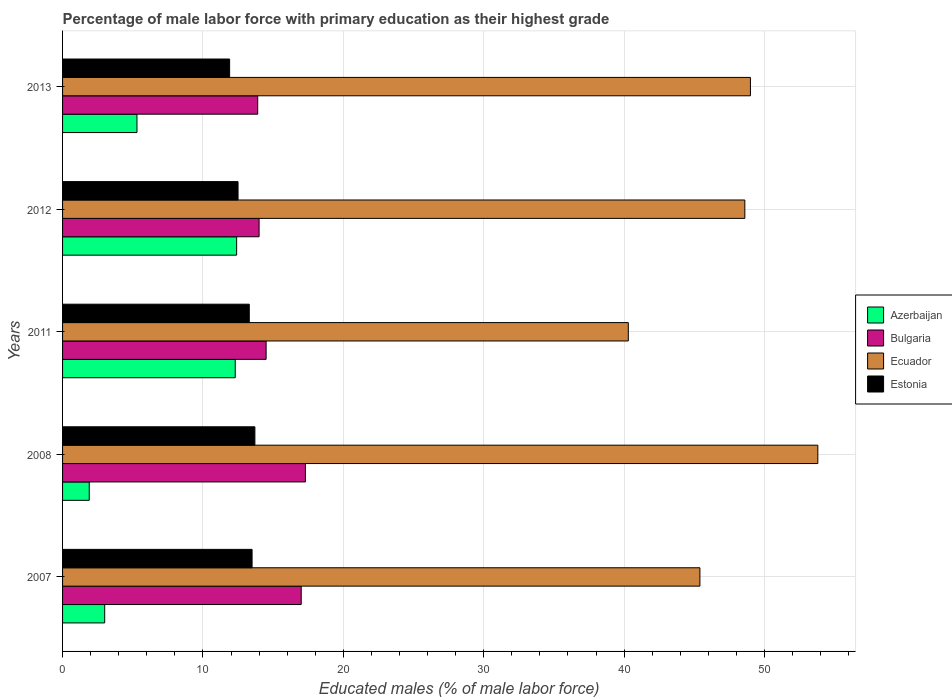How many different coloured bars are there?
Ensure brevity in your answer.  4. Are the number of bars per tick equal to the number of legend labels?
Offer a very short reply. Yes. How many bars are there on the 2nd tick from the top?
Provide a succinct answer. 4. How many bars are there on the 2nd tick from the bottom?
Offer a very short reply. 4. What is the percentage of male labor force with primary education in Bulgaria in 2013?
Ensure brevity in your answer.  13.9. Across all years, what is the maximum percentage of male labor force with primary education in Bulgaria?
Your response must be concise. 17.3. Across all years, what is the minimum percentage of male labor force with primary education in Azerbaijan?
Provide a succinct answer. 1.9. In which year was the percentage of male labor force with primary education in Ecuador minimum?
Ensure brevity in your answer.  2011. What is the total percentage of male labor force with primary education in Bulgaria in the graph?
Make the answer very short. 76.7. What is the difference between the percentage of male labor force with primary education in Estonia in 2012 and that in 2013?
Make the answer very short. 0.6. What is the difference between the percentage of male labor force with primary education in Bulgaria in 2013 and the percentage of male labor force with primary education in Estonia in 2007?
Provide a short and direct response. 0.4. What is the average percentage of male labor force with primary education in Azerbaijan per year?
Your response must be concise. 6.98. In the year 2012, what is the difference between the percentage of male labor force with primary education in Azerbaijan and percentage of male labor force with primary education in Ecuador?
Make the answer very short. -36.2. In how many years, is the percentage of male labor force with primary education in Ecuador greater than 6 %?
Provide a short and direct response. 5. What is the ratio of the percentage of male labor force with primary education in Azerbaijan in 2007 to that in 2012?
Offer a very short reply. 0.24. Is the percentage of male labor force with primary education in Azerbaijan in 2011 less than that in 2012?
Give a very brief answer. Yes. What is the difference between the highest and the second highest percentage of male labor force with primary education in Azerbaijan?
Your answer should be compact. 0.1. What is the difference between the highest and the lowest percentage of male labor force with primary education in Ecuador?
Your answer should be very brief. 13.5. In how many years, is the percentage of male labor force with primary education in Estonia greater than the average percentage of male labor force with primary education in Estonia taken over all years?
Provide a short and direct response. 3. Is it the case that in every year, the sum of the percentage of male labor force with primary education in Estonia and percentage of male labor force with primary education in Azerbaijan is greater than the sum of percentage of male labor force with primary education in Ecuador and percentage of male labor force with primary education in Bulgaria?
Offer a terse response. No. What does the 2nd bar from the top in 2007 represents?
Your response must be concise. Ecuador. Is it the case that in every year, the sum of the percentage of male labor force with primary education in Ecuador and percentage of male labor force with primary education in Bulgaria is greater than the percentage of male labor force with primary education in Azerbaijan?
Offer a very short reply. Yes. How many bars are there?
Keep it short and to the point. 20. Are all the bars in the graph horizontal?
Offer a very short reply. Yes. Are the values on the major ticks of X-axis written in scientific E-notation?
Your answer should be compact. No. Does the graph contain any zero values?
Give a very brief answer. No. Does the graph contain grids?
Provide a short and direct response. Yes. Where does the legend appear in the graph?
Provide a short and direct response. Center right. How are the legend labels stacked?
Provide a succinct answer. Vertical. What is the title of the graph?
Your answer should be very brief. Percentage of male labor force with primary education as their highest grade. What is the label or title of the X-axis?
Provide a succinct answer. Educated males (% of male labor force). What is the label or title of the Y-axis?
Give a very brief answer. Years. What is the Educated males (% of male labor force) of Azerbaijan in 2007?
Your response must be concise. 3. What is the Educated males (% of male labor force) of Bulgaria in 2007?
Your answer should be compact. 17. What is the Educated males (% of male labor force) in Ecuador in 2007?
Provide a succinct answer. 45.4. What is the Educated males (% of male labor force) of Estonia in 2007?
Make the answer very short. 13.5. What is the Educated males (% of male labor force) in Azerbaijan in 2008?
Give a very brief answer. 1.9. What is the Educated males (% of male labor force) in Bulgaria in 2008?
Provide a short and direct response. 17.3. What is the Educated males (% of male labor force) of Ecuador in 2008?
Your answer should be compact. 53.8. What is the Educated males (% of male labor force) in Estonia in 2008?
Ensure brevity in your answer.  13.7. What is the Educated males (% of male labor force) of Azerbaijan in 2011?
Provide a succinct answer. 12.3. What is the Educated males (% of male labor force) of Bulgaria in 2011?
Your answer should be compact. 14.5. What is the Educated males (% of male labor force) of Ecuador in 2011?
Your answer should be very brief. 40.3. What is the Educated males (% of male labor force) of Estonia in 2011?
Offer a very short reply. 13.3. What is the Educated males (% of male labor force) in Azerbaijan in 2012?
Provide a succinct answer. 12.4. What is the Educated males (% of male labor force) of Ecuador in 2012?
Provide a succinct answer. 48.6. What is the Educated males (% of male labor force) in Azerbaijan in 2013?
Your response must be concise. 5.3. What is the Educated males (% of male labor force) in Bulgaria in 2013?
Offer a very short reply. 13.9. What is the Educated males (% of male labor force) of Ecuador in 2013?
Provide a succinct answer. 49. What is the Educated males (% of male labor force) in Estonia in 2013?
Offer a very short reply. 11.9. Across all years, what is the maximum Educated males (% of male labor force) of Azerbaijan?
Offer a very short reply. 12.4. Across all years, what is the maximum Educated males (% of male labor force) in Bulgaria?
Offer a very short reply. 17.3. Across all years, what is the maximum Educated males (% of male labor force) in Ecuador?
Provide a succinct answer. 53.8. Across all years, what is the maximum Educated males (% of male labor force) in Estonia?
Ensure brevity in your answer.  13.7. Across all years, what is the minimum Educated males (% of male labor force) in Azerbaijan?
Make the answer very short. 1.9. Across all years, what is the minimum Educated males (% of male labor force) in Bulgaria?
Your answer should be very brief. 13.9. Across all years, what is the minimum Educated males (% of male labor force) of Ecuador?
Your response must be concise. 40.3. Across all years, what is the minimum Educated males (% of male labor force) of Estonia?
Offer a very short reply. 11.9. What is the total Educated males (% of male labor force) in Azerbaijan in the graph?
Your answer should be very brief. 34.9. What is the total Educated males (% of male labor force) in Bulgaria in the graph?
Ensure brevity in your answer.  76.7. What is the total Educated males (% of male labor force) of Ecuador in the graph?
Your response must be concise. 237.1. What is the total Educated males (% of male labor force) of Estonia in the graph?
Provide a succinct answer. 64.9. What is the difference between the Educated males (% of male labor force) in Azerbaijan in 2007 and that in 2008?
Give a very brief answer. 1.1. What is the difference between the Educated males (% of male labor force) in Bulgaria in 2007 and that in 2008?
Make the answer very short. -0.3. What is the difference between the Educated males (% of male labor force) in Ecuador in 2007 and that in 2011?
Keep it short and to the point. 5.1. What is the difference between the Educated males (% of male labor force) in Bulgaria in 2007 and that in 2012?
Give a very brief answer. 3. What is the difference between the Educated males (% of male labor force) of Ecuador in 2007 and that in 2012?
Provide a short and direct response. -3.2. What is the difference between the Educated males (% of male labor force) in Estonia in 2007 and that in 2012?
Your answer should be compact. 1. What is the difference between the Educated males (% of male labor force) of Ecuador in 2007 and that in 2013?
Provide a succinct answer. -3.6. What is the difference between the Educated males (% of male labor force) of Ecuador in 2008 and that in 2011?
Ensure brevity in your answer.  13.5. What is the difference between the Educated males (% of male labor force) of Estonia in 2008 and that in 2011?
Your response must be concise. 0.4. What is the difference between the Educated males (% of male labor force) in Bulgaria in 2008 and that in 2012?
Provide a succinct answer. 3.3. What is the difference between the Educated males (% of male labor force) in Azerbaijan in 2008 and that in 2013?
Give a very brief answer. -3.4. What is the difference between the Educated males (% of male labor force) of Bulgaria in 2008 and that in 2013?
Offer a very short reply. 3.4. What is the difference between the Educated males (% of male labor force) of Ecuador in 2008 and that in 2013?
Provide a short and direct response. 4.8. What is the difference between the Educated males (% of male labor force) of Bulgaria in 2011 and that in 2013?
Offer a terse response. 0.6. What is the difference between the Educated males (% of male labor force) of Estonia in 2011 and that in 2013?
Offer a terse response. 1.4. What is the difference between the Educated males (% of male labor force) in Bulgaria in 2012 and that in 2013?
Provide a short and direct response. 0.1. What is the difference between the Educated males (% of male labor force) in Ecuador in 2012 and that in 2013?
Your answer should be very brief. -0.4. What is the difference between the Educated males (% of male labor force) in Azerbaijan in 2007 and the Educated males (% of male labor force) in Bulgaria in 2008?
Give a very brief answer. -14.3. What is the difference between the Educated males (% of male labor force) in Azerbaijan in 2007 and the Educated males (% of male labor force) in Ecuador in 2008?
Your answer should be compact. -50.8. What is the difference between the Educated males (% of male labor force) of Azerbaijan in 2007 and the Educated males (% of male labor force) of Estonia in 2008?
Provide a short and direct response. -10.7. What is the difference between the Educated males (% of male labor force) of Bulgaria in 2007 and the Educated males (% of male labor force) of Ecuador in 2008?
Keep it short and to the point. -36.8. What is the difference between the Educated males (% of male labor force) of Bulgaria in 2007 and the Educated males (% of male labor force) of Estonia in 2008?
Ensure brevity in your answer.  3.3. What is the difference between the Educated males (% of male labor force) of Ecuador in 2007 and the Educated males (% of male labor force) of Estonia in 2008?
Keep it short and to the point. 31.7. What is the difference between the Educated males (% of male labor force) of Azerbaijan in 2007 and the Educated males (% of male labor force) of Bulgaria in 2011?
Your answer should be compact. -11.5. What is the difference between the Educated males (% of male labor force) of Azerbaijan in 2007 and the Educated males (% of male labor force) of Ecuador in 2011?
Offer a terse response. -37.3. What is the difference between the Educated males (% of male labor force) of Bulgaria in 2007 and the Educated males (% of male labor force) of Ecuador in 2011?
Make the answer very short. -23.3. What is the difference between the Educated males (% of male labor force) in Ecuador in 2007 and the Educated males (% of male labor force) in Estonia in 2011?
Your answer should be very brief. 32.1. What is the difference between the Educated males (% of male labor force) in Azerbaijan in 2007 and the Educated males (% of male labor force) in Bulgaria in 2012?
Your response must be concise. -11. What is the difference between the Educated males (% of male labor force) in Azerbaijan in 2007 and the Educated males (% of male labor force) in Ecuador in 2012?
Ensure brevity in your answer.  -45.6. What is the difference between the Educated males (% of male labor force) of Bulgaria in 2007 and the Educated males (% of male labor force) of Ecuador in 2012?
Provide a succinct answer. -31.6. What is the difference between the Educated males (% of male labor force) of Ecuador in 2007 and the Educated males (% of male labor force) of Estonia in 2012?
Offer a terse response. 32.9. What is the difference between the Educated males (% of male labor force) of Azerbaijan in 2007 and the Educated males (% of male labor force) of Bulgaria in 2013?
Give a very brief answer. -10.9. What is the difference between the Educated males (% of male labor force) in Azerbaijan in 2007 and the Educated males (% of male labor force) in Ecuador in 2013?
Offer a very short reply. -46. What is the difference between the Educated males (% of male labor force) of Azerbaijan in 2007 and the Educated males (% of male labor force) of Estonia in 2013?
Provide a succinct answer. -8.9. What is the difference between the Educated males (% of male labor force) of Bulgaria in 2007 and the Educated males (% of male labor force) of Ecuador in 2013?
Make the answer very short. -32. What is the difference between the Educated males (% of male labor force) of Ecuador in 2007 and the Educated males (% of male labor force) of Estonia in 2013?
Your answer should be compact. 33.5. What is the difference between the Educated males (% of male labor force) of Azerbaijan in 2008 and the Educated males (% of male labor force) of Ecuador in 2011?
Provide a short and direct response. -38.4. What is the difference between the Educated males (% of male labor force) of Bulgaria in 2008 and the Educated males (% of male labor force) of Estonia in 2011?
Your answer should be very brief. 4. What is the difference between the Educated males (% of male labor force) of Ecuador in 2008 and the Educated males (% of male labor force) of Estonia in 2011?
Your answer should be compact. 40.5. What is the difference between the Educated males (% of male labor force) of Azerbaijan in 2008 and the Educated males (% of male labor force) of Bulgaria in 2012?
Offer a terse response. -12.1. What is the difference between the Educated males (% of male labor force) of Azerbaijan in 2008 and the Educated males (% of male labor force) of Ecuador in 2012?
Give a very brief answer. -46.7. What is the difference between the Educated males (% of male labor force) in Bulgaria in 2008 and the Educated males (% of male labor force) in Ecuador in 2012?
Your answer should be compact. -31.3. What is the difference between the Educated males (% of male labor force) of Bulgaria in 2008 and the Educated males (% of male labor force) of Estonia in 2012?
Keep it short and to the point. 4.8. What is the difference between the Educated males (% of male labor force) in Ecuador in 2008 and the Educated males (% of male labor force) in Estonia in 2012?
Your response must be concise. 41.3. What is the difference between the Educated males (% of male labor force) of Azerbaijan in 2008 and the Educated males (% of male labor force) of Ecuador in 2013?
Provide a short and direct response. -47.1. What is the difference between the Educated males (% of male labor force) in Bulgaria in 2008 and the Educated males (% of male labor force) in Ecuador in 2013?
Provide a short and direct response. -31.7. What is the difference between the Educated males (% of male labor force) in Bulgaria in 2008 and the Educated males (% of male labor force) in Estonia in 2013?
Your response must be concise. 5.4. What is the difference between the Educated males (% of male labor force) in Ecuador in 2008 and the Educated males (% of male labor force) in Estonia in 2013?
Keep it short and to the point. 41.9. What is the difference between the Educated males (% of male labor force) in Azerbaijan in 2011 and the Educated males (% of male labor force) in Bulgaria in 2012?
Provide a short and direct response. -1.7. What is the difference between the Educated males (% of male labor force) in Azerbaijan in 2011 and the Educated males (% of male labor force) in Ecuador in 2012?
Your answer should be very brief. -36.3. What is the difference between the Educated males (% of male labor force) in Azerbaijan in 2011 and the Educated males (% of male labor force) in Estonia in 2012?
Your response must be concise. -0.2. What is the difference between the Educated males (% of male labor force) in Bulgaria in 2011 and the Educated males (% of male labor force) in Ecuador in 2012?
Offer a terse response. -34.1. What is the difference between the Educated males (% of male labor force) in Ecuador in 2011 and the Educated males (% of male labor force) in Estonia in 2012?
Your answer should be compact. 27.8. What is the difference between the Educated males (% of male labor force) of Azerbaijan in 2011 and the Educated males (% of male labor force) of Ecuador in 2013?
Your response must be concise. -36.7. What is the difference between the Educated males (% of male labor force) of Bulgaria in 2011 and the Educated males (% of male labor force) of Ecuador in 2013?
Ensure brevity in your answer.  -34.5. What is the difference between the Educated males (% of male labor force) in Ecuador in 2011 and the Educated males (% of male labor force) in Estonia in 2013?
Give a very brief answer. 28.4. What is the difference between the Educated males (% of male labor force) of Azerbaijan in 2012 and the Educated males (% of male labor force) of Bulgaria in 2013?
Make the answer very short. -1.5. What is the difference between the Educated males (% of male labor force) of Azerbaijan in 2012 and the Educated males (% of male labor force) of Ecuador in 2013?
Give a very brief answer. -36.6. What is the difference between the Educated males (% of male labor force) in Azerbaijan in 2012 and the Educated males (% of male labor force) in Estonia in 2013?
Give a very brief answer. 0.5. What is the difference between the Educated males (% of male labor force) in Bulgaria in 2012 and the Educated males (% of male labor force) in Ecuador in 2013?
Your answer should be very brief. -35. What is the difference between the Educated males (% of male labor force) in Ecuador in 2012 and the Educated males (% of male labor force) in Estonia in 2013?
Your response must be concise. 36.7. What is the average Educated males (% of male labor force) in Azerbaijan per year?
Give a very brief answer. 6.98. What is the average Educated males (% of male labor force) of Bulgaria per year?
Provide a short and direct response. 15.34. What is the average Educated males (% of male labor force) of Ecuador per year?
Your answer should be very brief. 47.42. What is the average Educated males (% of male labor force) of Estonia per year?
Your response must be concise. 12.98. In the year 2007, what is the difference between the Educated males (% of male labor force) of Azerbaijan and Educated males (% of male labor force) of Bulgaria?
Your answer should be very brief. -14. In the year 2007, what is the difference between the Educated males (% of male labor force) in Azerbaijan and Educated males (% of male labor force) in Ecuador?
Your answer should be compact. -42.4. In the year 2007, what is the difference between the Educated males (% of male labor force) of Azerbaijan and Educated males (% of male labor force) of Estonia?
Your answer should be very brief. -10.5. In the year 2007, what is the difference between the Educated males (% of male labor force) of Bulgaria and Educated males (% of male labor force) of Ecuador?
Ensure brevity in your answer.  -28.4. In the year 2007, what is the difference between the Educated males (% of male labor force) of Ecuador and Educated males (% of male labor force) of Estonia?
Your answer should be very brief. 31.9. In the year 2008, what is the difference between the Educated males (% of male labor force) in Azerbaijan and Educated males (% of male labor force) in Bulgaria?
Your answer should be compact. -15.4. In the year 2008, what is the difference between the Educated males (% of male labor force) in Azerbaijan and Educated males (% of male labor force) in Ecuador?
Offer a very short reply. -51.9. In the year 2008, what is the difference between the Educated males (% of male labor force) of Bulgaria and Educated males (% of male labor force) of Ecuador?
Your answer should be very brief. -36.5. In the year 2008, what is the difference between the Educated males (% of male labor force) in Bulgaria and Educated males (% of male labor force) in Estonia?
Provide a short and direct response. 3.6. In the year 2008, what is the difference between the Educated males (% of male labor force) of Ecuador and Educated males (% of male labor force) of Estonia?
Make the answer very short. 40.1. In the year 2011, what is the difference between the Educated males (% of male labor force) of Azerbaijan and Educated males (% of male labor force) of Ecuador?
Provide a short and direct response. -28. In the year 2011, what is the difference between the Educated males (% of male labor force) of Bulgaria and Educated males (% of male labor force) of Ecuador?
Offer a terse response. -25.8. In the year 2011, what is the difference between the Educated males (% of male labor force) of Bulgaria and Educated males (% of male labor force) of Estonia?
Offer a very short reply. 1.2. In the year 2012, what is the difference between the Educated males (% of male labor force) in Azerbaijan and Educated males (% of male labor force) in Ecuador?
Offer a very short reply. -36.2. In the year 2012, what is the difference between the Educated males (% of male labor force) in Azerbaijan and Educated males (% of male labor force) in Estonia?
Provide a short and direct response. -0.1. In the year 2012, what is the difference between the Educated males (% of male labor force) of Bulgaria and Educated males (% of male labor force) of Ecuador?
Keep it short and to the point. -34.6. In the year 2012, what is the difference between the Educated males (% of male labor force) of Bulgaria and Educated males (% of male labor force) of Estonia?
Provide a succinct answer. 1.5. In the year 2012, what is the difference between the Educated males (% of male labor force) in Ecuador and Educated males (% of male labor force) in Estonia?
Keep it short and to the point. 36.1. In the year 2013, what is the difference between the Educated males (% of male labor force) in Azerbaijan and Educated males (% of male labor force) in Bulgaria?
Your answer should be compact. -8.6. In the year 2013, what is the difference between the Educated males (% of male labor force) in Azerbaijan and Educated males (% of male labor force) in Ecuador?
Offer a terse response. -43.7. In the year 2013, what is the difference between the Educated males (% of male labor force) of Azerbaijan and Educated males (% of male labor force) of Estonia?
Your response must be concise. -6.6. In the year 2013, what is the difference between the Educated males (% of male labor force) of Bulgaria and Educated males (% of male labor force) of Ecuador?
Give a very brief answer. -35.1. In the year 2013, what is the difference between the Educated males (% of male labor force) of Bulgaria and Educated males (% of male labor force) of Estonia?
Ensure brevity in your answer.  2. In the year 2013, what is the difference between the Educated males (% of male labor force) in Ecuador and Educated males (% of male labor force) in Estonia?
Provide a succinct answer. 37.1. What is the ratio of the Educated males (% of male labor force) in Azerbaijan in 2007 to that in 2008?
Provide a short and direct response. 1.58. What is the ratio of the Educated males (% of male labor force) in Bulgaria in 2007 to that in 2008?
Provide a short and direct response. 0.98. What is the ratio of the Educated males (% of male labor force) in Ecuador in 2007 to that in 2008?
Your response must be concise. 0.84. What is the ratio of the Educated males (% of male labor force) in Estonia in 2007 to that in 2008?
Make the answer very short. 0.99. What is the ratio of the Educated males (% of male labor force) of Azerbaijan in 2007 to that in 2011?
Provide a succinct answer. 0.24. What is the ratio of the Educated males (% of male labor force) of Bulgaria in 2007 to that in 2011?
Provide a succinct answer. 1.17. What is the ratio of the Educated males (% of male labor force) of Ecuador in 2007 to that in 2011?
Your answer should be compact. 1.13. What is the ratio of the Educated males (% of male labor force) of Estonia in 2007 to that in 2011?
Offer a terse response. 1.01. What is the ratio of the Educated males (% of male labor force) of Azerbaijan in 2007 to that in 2012?
Offer a very short reply. 0.24. What is the ratio of the Educated males (% of male labor force) of Bulgaria in 2007 to that in 2012?
Your response must be concise. 1.21. What is the ratio of the Educated males (% of male labor force) of Ecuador in 2007 to that in 2012?
Your response must be concise. 0.93. What is the ratio of the Educated males (% of male labor force) in Azerbaijan in 2007 to that in 2013?
Make the answer very short. 0.57. What is the ratio of the Educated males (% of male labor force) in Bulgaria in 2007 to that in 2013?
Offer a very short reply. 1.22. What is the ratio of the Educated males (% of male labor force) in Ecuador in 2007 to that in 2013?
Your answer should be compact. 0.93. What is the ratio of the Educated males (% of male labor force) of Estonia in 2007 to that in 2013?
Provide a short and direct response. 1.13. What is the ratio of the Educated males (% of male labor force) in Azerbaijan in 2008 to that in 2011?
Give a very brief answer. 0.15. What is the ratio of the Educated males (% of male labor force) of Bulgaria in 2008 to that in 2011?
Offer a terse response. 1.19. What is the ratio of the Educated males (% of male labor force) in Ecuador in 2008 to that in 2011?
Make the answer very short. 1.33. What is the ratio of the Educated males (% of male labor force) of Estonia in 2008 to that in 2011?
Make the answer very short. 1.03. What is the ratio of the Educated males (% of male labor force) of Azerbaijan in 2008 to that in 2012?
Make the answer very short. 0.15. What is the ratio of the Educated males (% of male labor force) in Bulgaria in 2008 to that in 2012?
Your answer should be compact. 1.24. What is the ratio of the Educated males (% of male labor force) in Ecuador in 2008 to that in 2012?
Your answer should be very brief. 1.11. What is the ratio of the Educated males (% of male labor force) in Estonia in 2008 to that in 2012?
Provide a succinct answer. 1.1. What is the ratio of the Educated males (% of male labor force) in Azerbaijan in 2008 to that in 2013?
Give a very brief answer. 0.36. What is the ratio of the Educated males (% of male labor force) in Bulgaria in 2008 to that in 2013?
Ensure brevity in your answer.  1.24. What is the ratio of the Educated males (% of male labor force) of Ecuador in 2008 to that in 2013?
Your answer should be very brief. 1.1. What is the ratio of the Educated males (% of male labor force) in Estonia in 2008 to that in 2013?
Provide a succinct answer. 1.15. What is the ratio of the Educated males (% of male labor force) of Azerbaijan in 2011 to that in 2012?
Ensure brevity in your answer.  0.99. What is the ratio of the Educated males (% of male labor force) in Bulgaria in 2011 to that in 2012?
Provide a succinct answer. 1.04. What is the ratio of the Educated males (% of male labor force) of Ecuador in 2011 to that in 2012?
Offer a very short reply. 0.83. What is the ratio of the Educated males (% of male labor force) of Estonia in 2011 to that in 2012?
Give a very brief answer. 1.06. What is the ratio of the Educated males (% of male labor force) of Azerbaijan in 2011 to that in 2013?
Offer a terse response. 2.32. What is the ratio of the Educated males (% of male labor force) in Bulgaria in 2011 to that in 2013?
Your answer should be very brief. 1.04. What is the ratio of the Educated males (% of male labor force) of Ecuador in 2011 to that in 2013?
Your answer should be very brief. 0.82. What is the ratio of the Educated males (% of male labor force) in Estonia in 2011 to that in 2013?
Your answer should be very brief. 1.12. What is the ratio of the Educated males (% of male labor force) of Azerbaijan in 2012 to that in 2013?
Ensure brevity in your answer.  2.34. What is the ratio of the Educated males (% of male labor force) of Ecuador in 2012 to that in 2013?
Give a very brief answer. 0.99. What is the ratio of the Educated males (% of male labor force) of Estonia in 2012 to that in 2013?
Your answer should be compact. 1.05. What is the difference between the highest and the second highest Educated males (% of male labor force) of Azerbaijan?
Your answer should be very brief. 0.1. What is the difference between the highest and the second highest Educated males (% of male labor force) in Bulgaria?
Ensure brevity in your answer.  0.3. What is the difference between the highest and the second highest Educated males (% of male labor force) in Ecuador?
Offer a very short reply. 4.8. What is the difference between the highest and the second highest Educated males (% of male labor force) of Estonia?
Make the answer very short. 0.2. What is the difference between the highest and the lowest Educated males (% of male labor force) of Azerbaijan?
Make the answer very short. 10.5. 